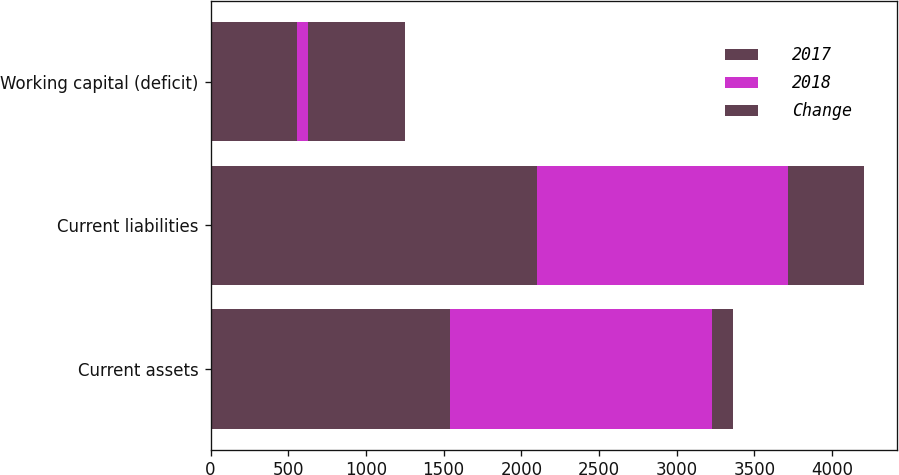Convert chart to OTSL. <chart><loc_0><loc_0><loc_500><loc_500><stacked_bar_chart><ecel><fcel>Current assets<fcel>Current liabilities<fcel>Working capital (deficit)<nl><fcel>2017<fcel>1543.8<fcel>2102.4<fcel>558.6<nl><fcel>2018<fcel>1682.6<fcel>1614.1<fcel>68.5<nl><fcel>Change<fcel>138.8<fcel>488.3<fcel>627.1<nl></chart> 